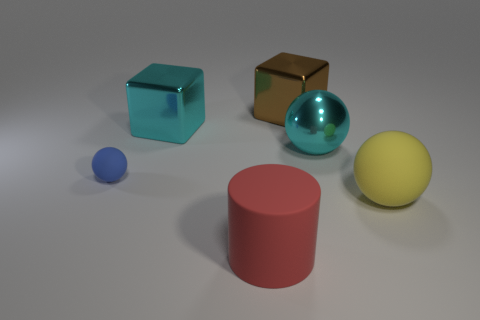Add 2 yellow rubber balls. How many objects exist? 8 Subtract all blocks. How many objects are left? 4 Subtract 0 blue blocks. How many objects are left? 6 Subtract all gray matte cylinders. Subtract all metal cubes. How many objects are left? 4 Add 1 red objects. How many red objects are left? 2 Add 5 metal spheres. How many metal spheres exist? 6 